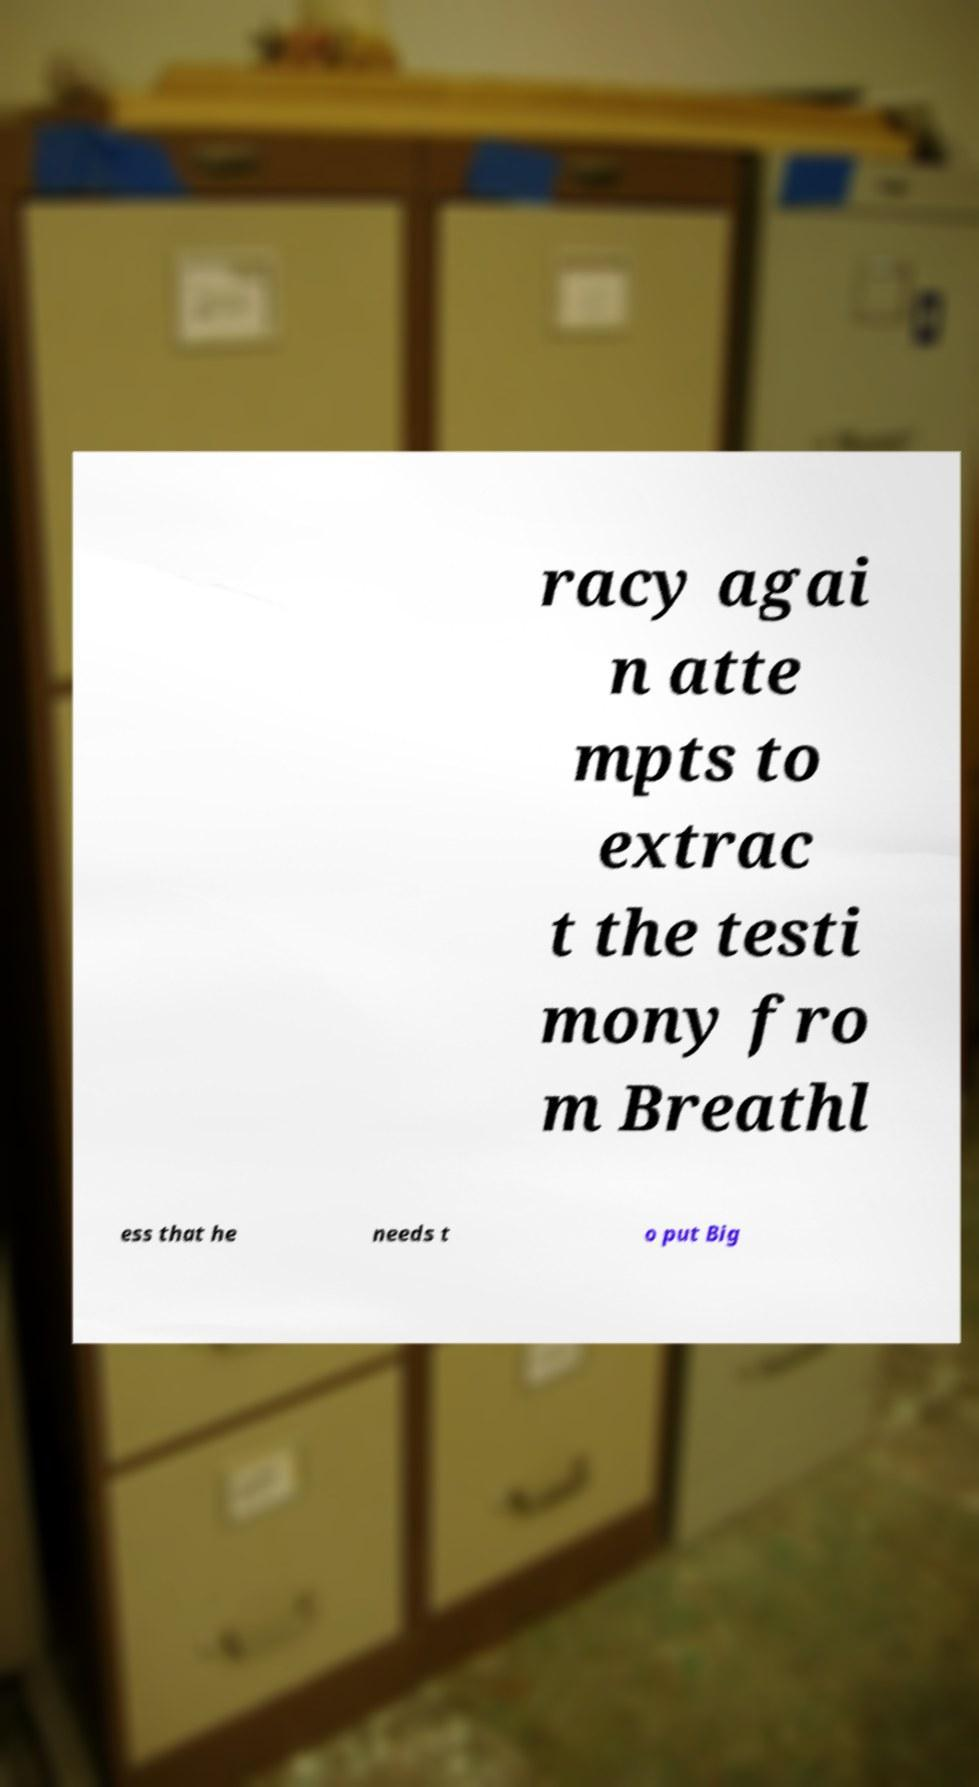Could you extract and type out the text from this image? racy agai n atte mpts to extrac t the testi mony fro m Breathl ess that he needs t o put Big 